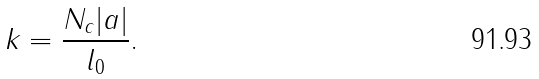<formula> <loc_0><loc_0><loc_500><loc_500>k = \frac { N _ { c } | a | } { l _ { 0 } } .</formula> 